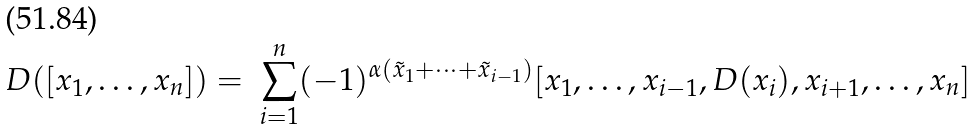Convert formula to latex. <formula><loc_0><loc_0><loc_500><loc_500>D ( [ x _ { 1 } , \dots , x _ { n } ] ) = \ \sum _ { i = 1 } ^ { n } ( - 1 ) ^ { \alpha ( { \tilde { x } } _ { 1 } + \dots + { \tilde { x } } _ { i - 1 } ) } [ x _ { 1 } , \dots , x _ { i - 1 } , D ( x _ { i } ) , x _ { i + 1 } , \dots , x _ { n } ]</formula> 